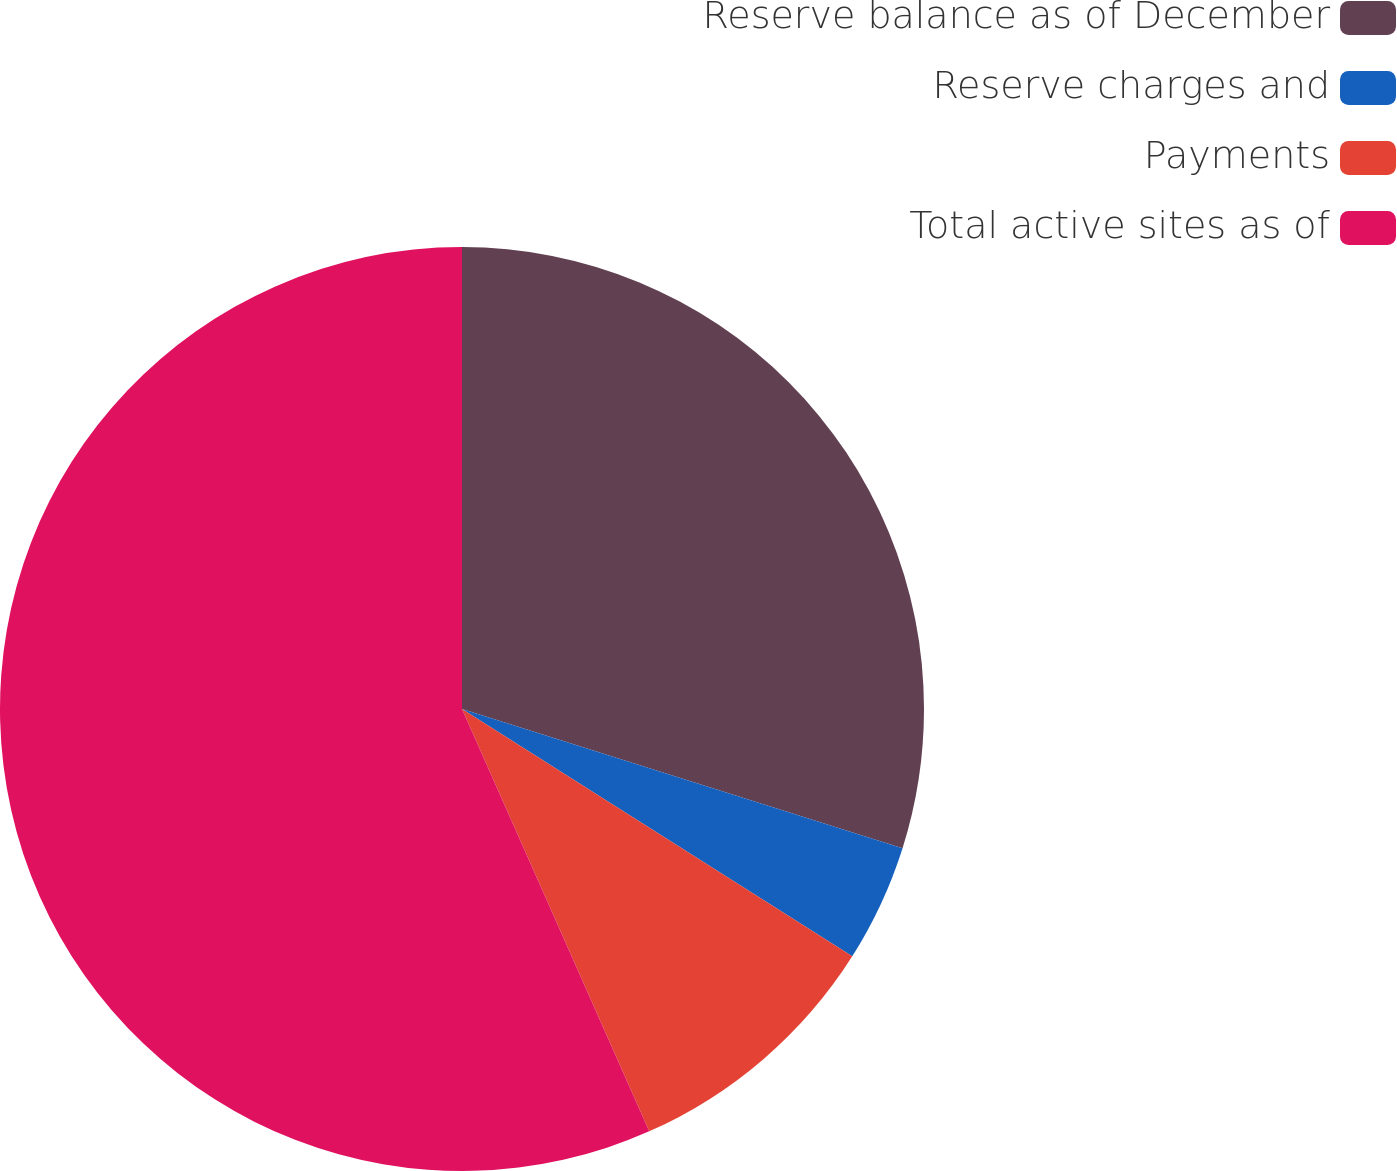Convert chart. <chart><loc_0><loc_0><loc_500><loc_500><pie_chart><fcel>Reserve balance as of December<fcel>Reserve charges and<fcel>Payments<fcel>Total active sites as of<nl><fcel>29.87%<fcel>4.12%<fcel>9.37%<fcel>56.64%<nl></chart> 